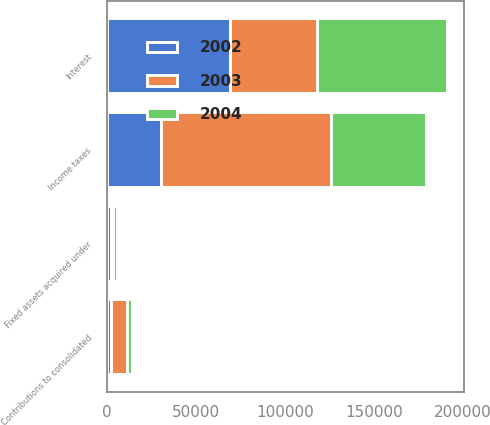<chart> <loc_0><loc_0><loc_500><loc_500><stacked_bar_chart><ecel><fcel>Income taxes<fcel>Interest<fcel>Fixed assets acquired under<fcel>Contributions to consolidated<nl><fcel>2003<fcel>95943<fcel>48822<fcel>1295<fcel>9167<nl><fcel>2004<fcel>53074<fcel>73278<fcel>2283<fcel>2645<nl><fcel>2002<fcel>30217<fcel>69114<fcel>2356<fcel>2154<nl></chart> 